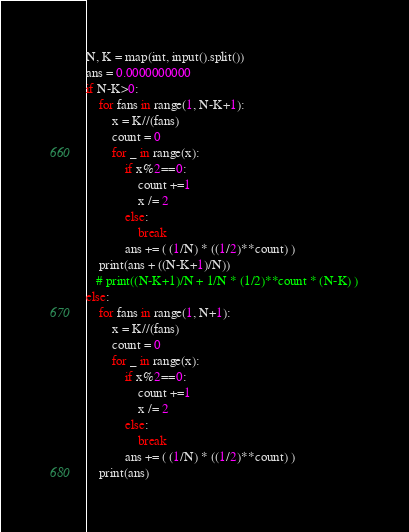Convert code to text. <code><loc_0><loc_0><loc_500><loc_500><_Python_>N, K = map(int, input().split())
ans = 0.0000000000
if N-K>0:
    for fans in range(1, N-K+1):
        x = K//(fans)
        count = 0
        for _ in range(x):
            if x%2==0:
                count +=1
                x /= 2
            else:
                break
            ans += ( (1/N) * ((1/2)**count) )
    print(ans + ((N-K+1)/N))
   # print((N-K+1)/N + 1/N * (1/2)**count * (N-K) )
else:
    for fans in range(1, N+1):
        x = K//(fans)
        count = 0
        for _ in range(x):
            if x%2==0:
                count +=1
                x /= 2
            else:
                break
            ans += ( (1/N) * ((1/2)**count) )
    print(ans)



</code> 